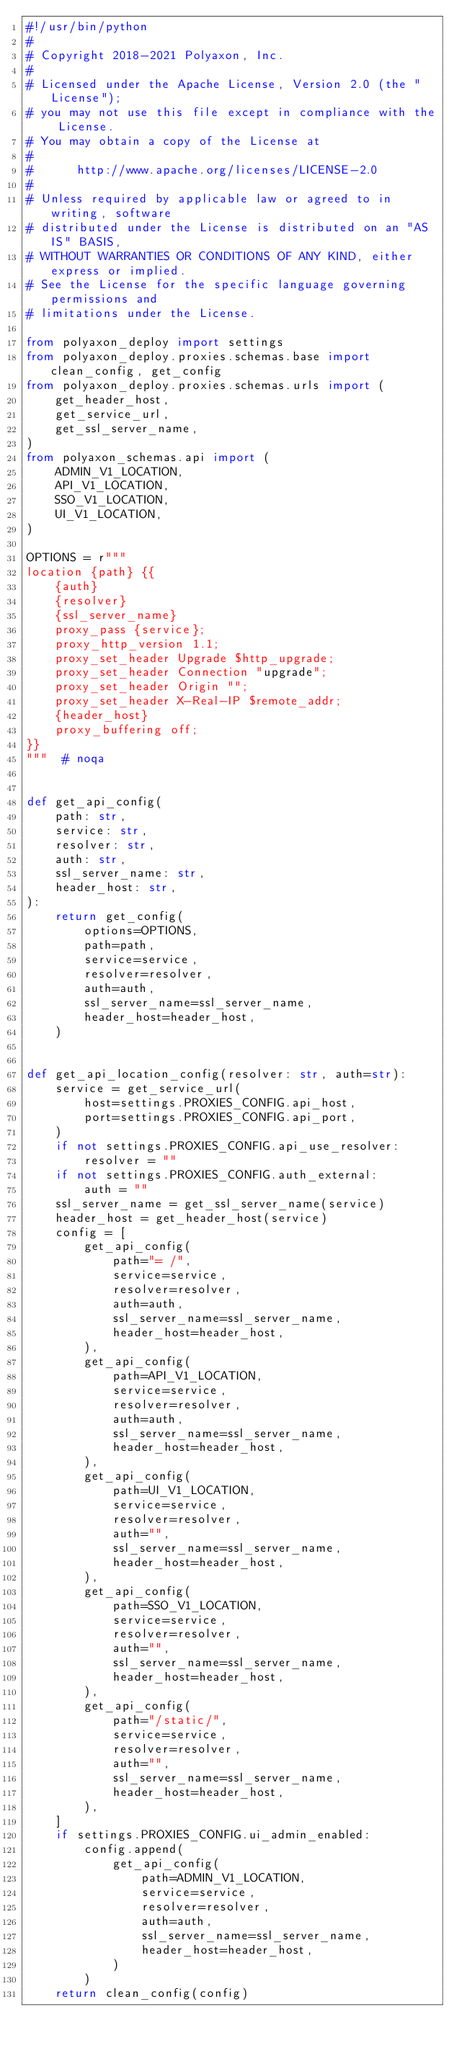<code> <loc_0><loc_0><loc_500><loc_500><_Python_>#!/usr/bin/python
#
# Copyright 2018-2021 Polyaxon, Inc.
#
# Licensed under the Apache License, Version 2.0 (the "License");
# you may not use this file except in compliance with the License.
# You may obtain a copy of the License at
#
#      http://www.apache.org/licenses/LICENSE-2.0
#
# Unless required by applicable law or agreed to in writing, software
# distributed under the License is distributed on an "AS IS" BASIS,
# WITHOUT WARRANTIES OR CONDITIONS OF ANY KIND, either express or implied.
# See the License for the specific language governing permissions and
# limitations under the License.

from polyaxon_deploy import settings
from polyaxon_deploy.proxies.schemas.base import clean_config, get_config
from polyaxon_deploy.proxies.schemas.urls import (
    get_header_host,
    get_service_url,
    get_ssl_server_name,
)
from polyaxon_schemas.api import (
    ADMIN_V1_LOCATION,
    API_V1_LOCATION,
    SSO_V1_LOCATION,
    UI_V1_LOCATION,
)

OPTIONS = r"""
location {path} {{
    {auth}
    {resolver}
    {ssl_server_name}
    proxy_pass {service};
    proxy_http_version 1.1;
    proxy_set_header Upgrade $http_upgrade;
    proxy_set_header Connection "upgrade";
    proxy_set_header Origin "";
    proxy_set_header X-Real-IP $remote_addr;
    {header_host}
    proxy_buffering off;
}}
"""  # noqa


def get_api_config(
    path: str,
    service: str,
    resolver: str,
    auth: str,
    ssl_server_name: str,
    header_host: str,
):
    return get_config(
        options=OPTIONS,
        path=path,
        service=service,
        resolver=resolver,
        auth=auth,
        ssl_server_name=ssl_server_name,
        header_host=header_host,
    )


def get_api_location_config(resolver: str, auth=str):
    service = get_service_url(
        host=settings.PROXIES_CONFIG.api_host,
        port=settings.PROXIES_CONFIG.api_port,
    )
    if not settings.PROXIES_CONFIG.api_use_resolver:
        resolver = ""
    if not settings.PROXIES_CONFIG.auth_external:
        auth = ""
    ssl_server_name = get_ssl_server_name(service)
    header_host = get_header_host(service)
    config = [
        get_api_config(
            path="= /",
            service=service,
            resolver=resolver,
            auth=auth,
            ssl_server_name=ssl_server_name,
            header_host=header_host,
        ),
        get_api_config(
            path=API_V1_LOCATION,
            service=service,
            resolver=resolver,
            auth=auth,
            ssl_server_name=ssl_server_name,
            header_host=header_host,
        ),
        get_api_config(
            path=UI_V1_LOCATION,
            service=service,
            resolver=resolver,
            auth="",
            ssl_server_name=ssl_server_name,
            header_host=header_host,
        ),
        get_api_config(
            path=SSO_V1_LOCATION,
            service=service,
            resolver=resolver,
            auth="",
            ssl_server_name=ssl_server_name,
            header_host=header_host,
        ),
        get_api_config(
            path="/static/",
            service=service,
            resolver=resolver,
            auth="",
            ssl_server_name=ssl_server_name,
            header_host=header_host,
        ),
    ]
    if settings.PROXIES_CONFIG.ui_admin_enabled:
        config.append(
            get_api_config(
                path=ADMIN_V1_LOCATION,
                service=service,
                resolver=resolver,
                auth=auth,
                ssl_server_name=ssl_server_name,
                header_host=header_host,
            )
        )
    return clean_config(config)
</code> 